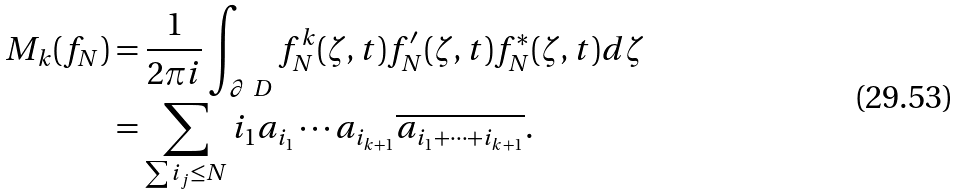Convert formula to latex. <formula><loc_0><loc_0><loc_500><loc_500>M _ { k } ( f _ { N } ) & = \frac { 1 } { 2 \pi i } \int _ { \partial \ D } f _ { N } ^ { k } ( \zeta , t ) f _ { N } ^ { \prime } ( \zeta , t ) { f _ { N } ^ { * } } ( { \zeta } , t ) d \zeta \\ & = \sum _ { \sum i _ { j } \leq N } i _ { 1 } a _ { i _ { 1 } } \cdots a _ { i _ { k + 1 } } \overline { a _ { i _ { 1 } + \cdots + i _ { k + 1 } } } .</formula> 